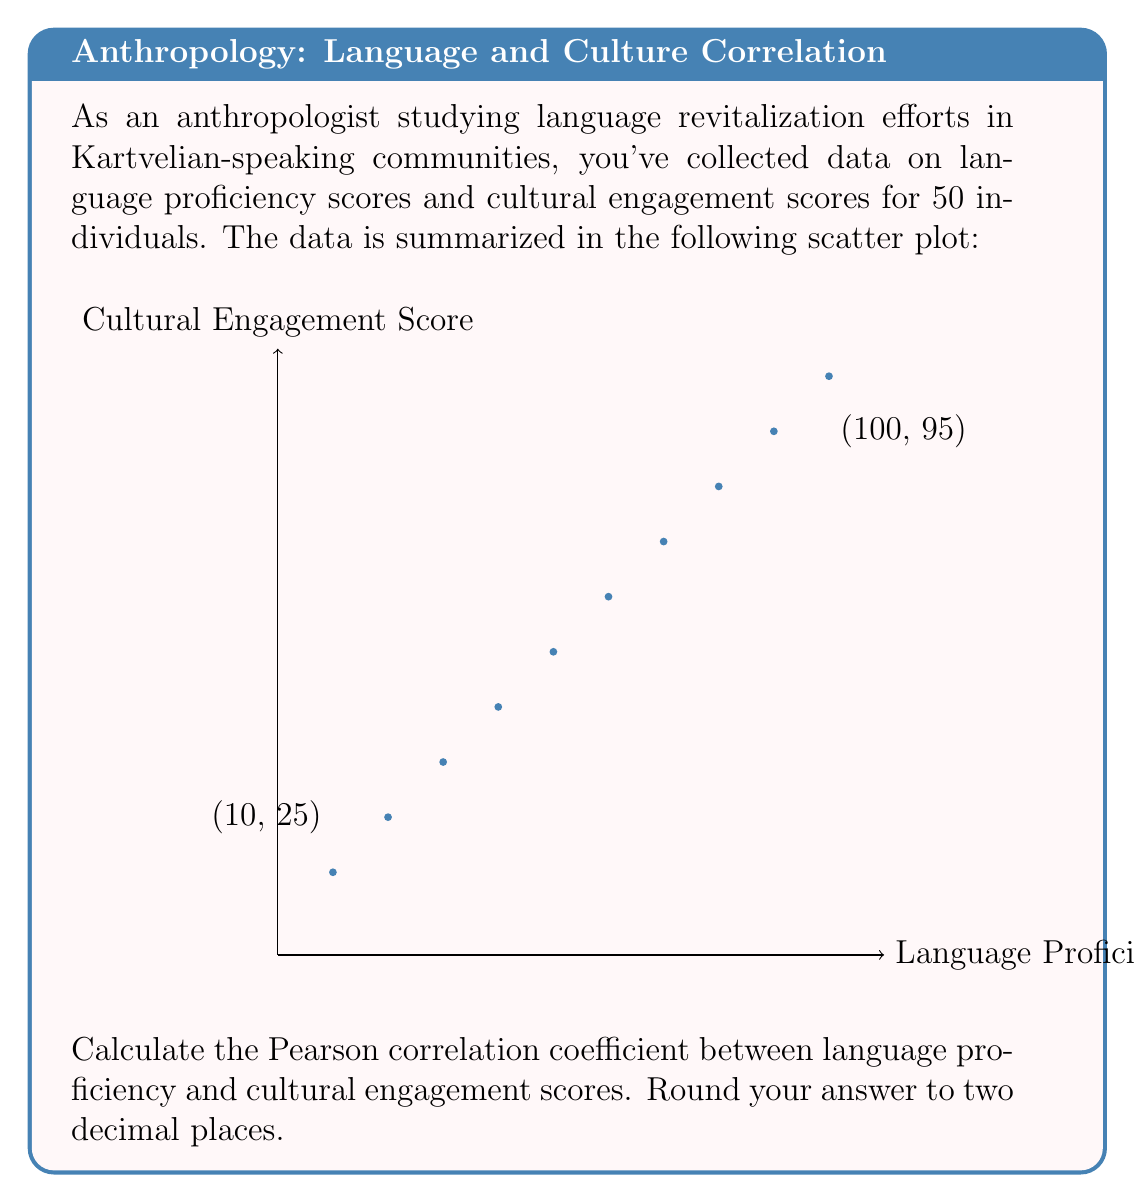What is the answer to this math problem? To calculate the Pearson correlation coefficient (r), we'll use the formula:

$$ r = \frac{\sum_{i=1}^{n} (x_i - \bar{x})(y_i - \bar{y})}{\sqrt{\sum_{i=1}^{n} (x_i - \bar{x})^2 \sum_{i=1}^{n} (y_i - \bar{y})^2}} $$

Where:
$x_i$ and $y_i$ are the individual sample points
$\bar{x}$ and $\bar{y}$ are the sample means

Step 1: Calculate the means
$\bar{x} = \frac{10 + 20 + 30 + 40 + 50 + 60 + 70 + 80 + 90 + 100}{10} = 55$
$\bar{y} = \frac{15 + 25 + 35 + 45 + 55 + 65 + 75 + 85 + 95 + 105}{10} = 60$

Step 2: Calculate $(x_i - \bar{x})(y_i - \bar{y})$, $(x_i - \bar{x})^2$, and $(y_i - \bar{y})^2$ for each point

Step 3: Sum up the results
$\sum (x_i - \bar{x})(y_i - \bar{y}) = 8250$
$\sum (x_i - \bar{x})^2 = 8250$
$\sum (y_i - \bar{y})^2 = 8250$

Step 4: Apply the formula
$$ r = \frac{8250}{\sqrt{8250 \cdot 8250}} = \frac{8250}{8250} = 1 $$

Step 5: Round to two decimal places
$r = 1.00$
Answer: $1.00$ 